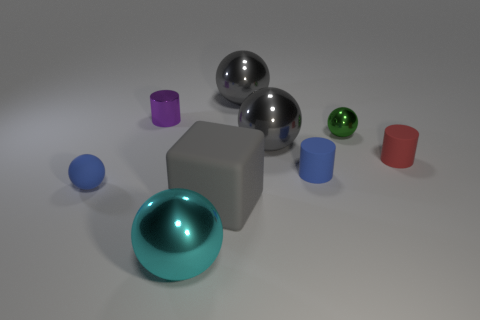Can you tell me what materials the objects in the image might be made from? The objects in the image appear to have different material properties. The spheres and cylinders have a shiny, reflective surface suggesting they could be made of metal or plastic. The cube in the center has a matte finish which could indicate a material like stone or unpolished metal. 